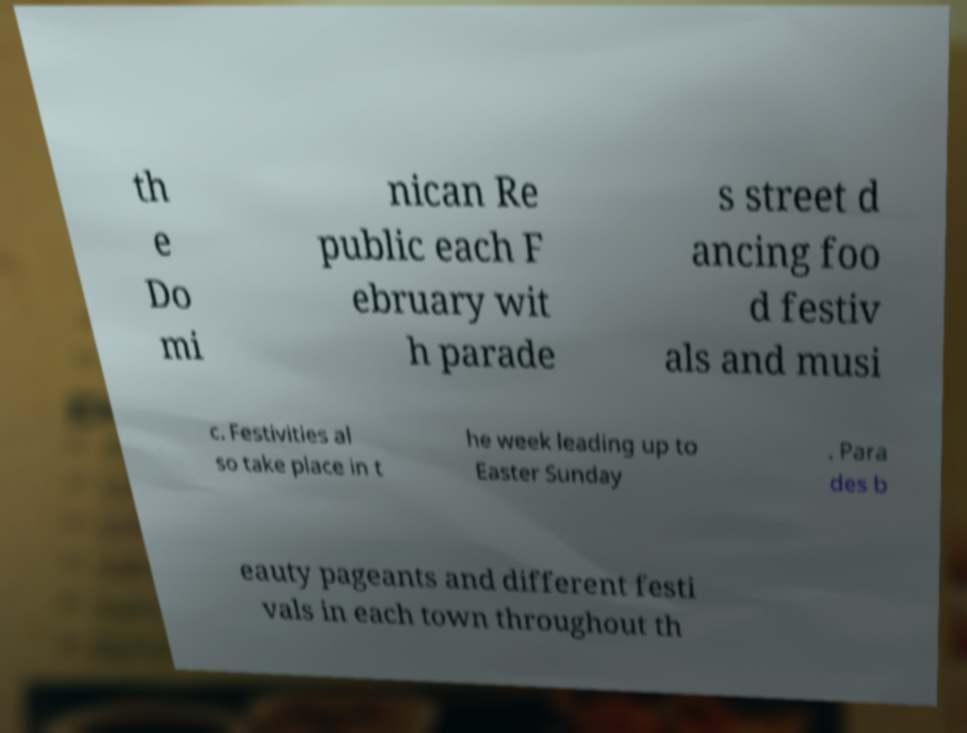For documentation purposes, I need the text within this image transcribed. Could you provide that? th e Do mi nican Re public each F ebruary wit h parade s street d ancing foo d festiv als and musi c. Festivities al so take place in t he week leading up to Easter Sunday . Para des b eauty pageants and different festi vals in each town throughout th 